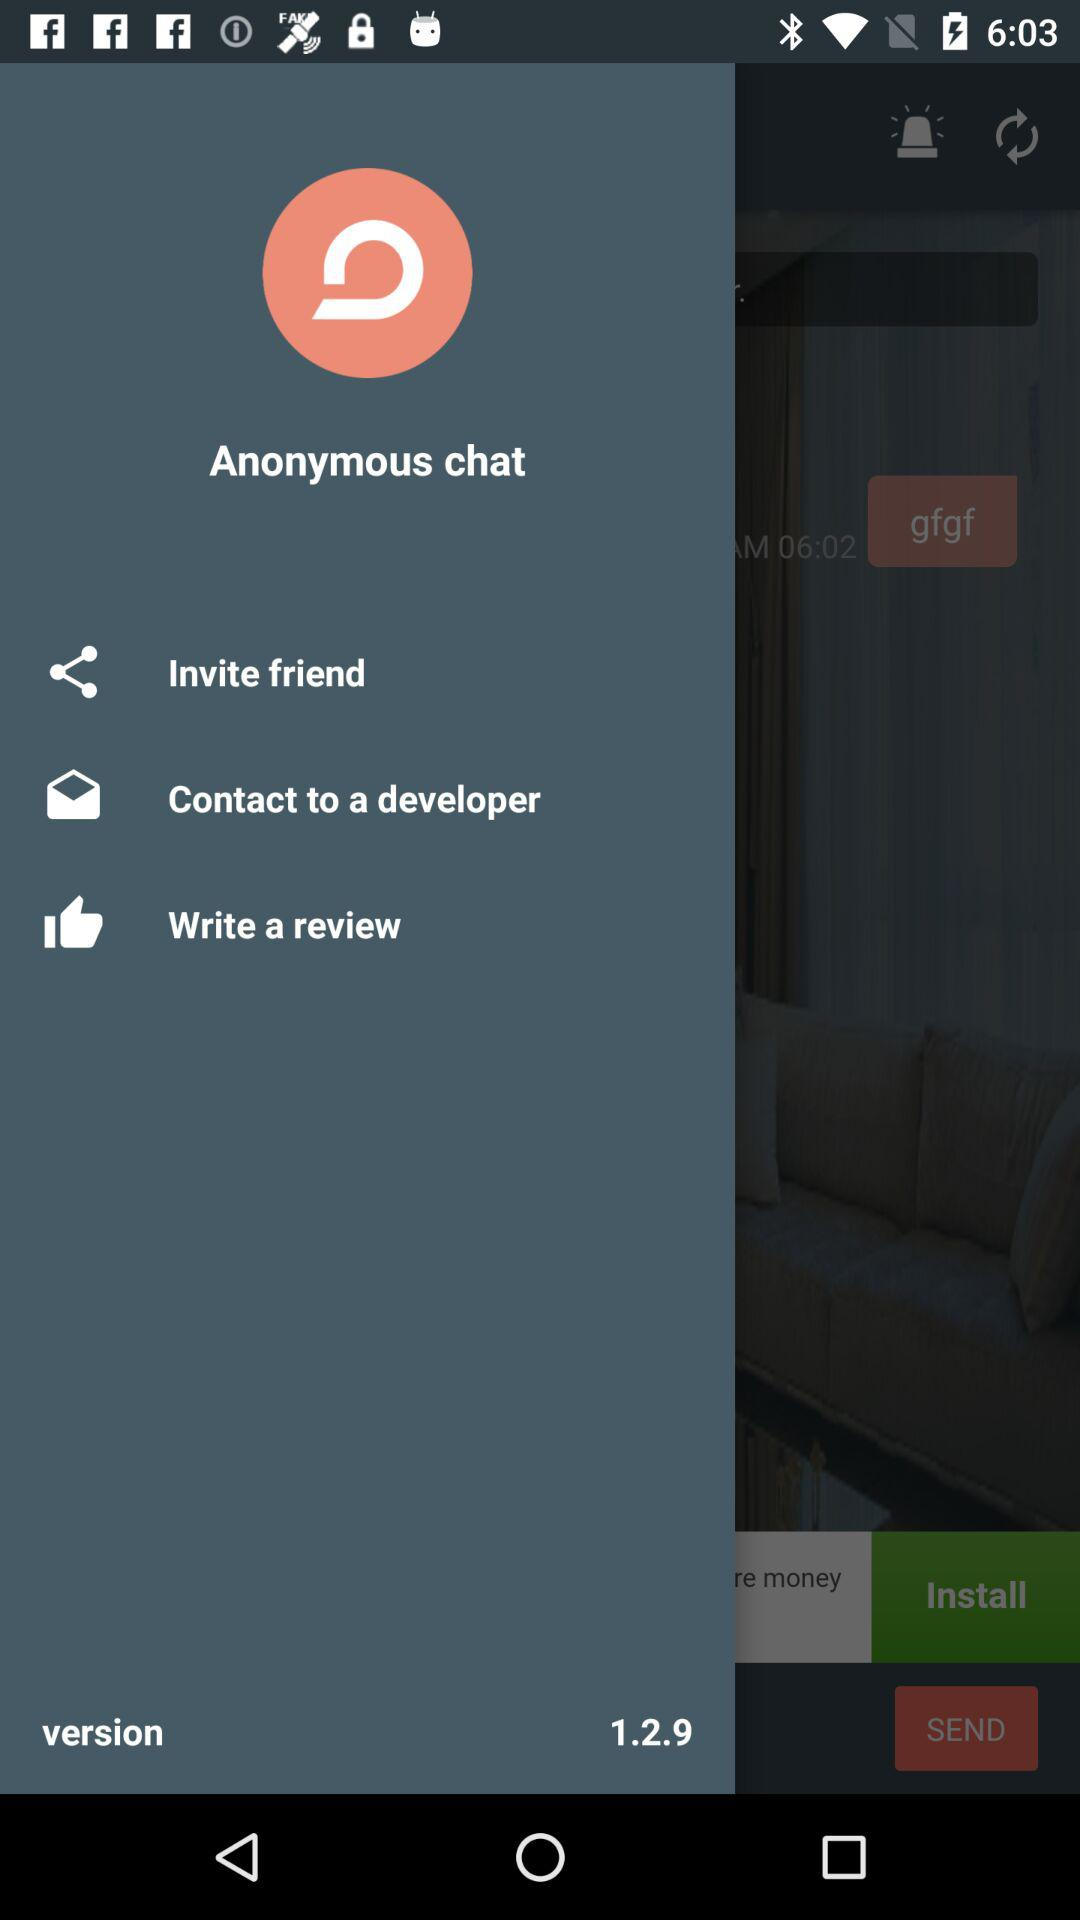What is the version number of this app?
Answer the question using a single word or phrase. 1.2.9 